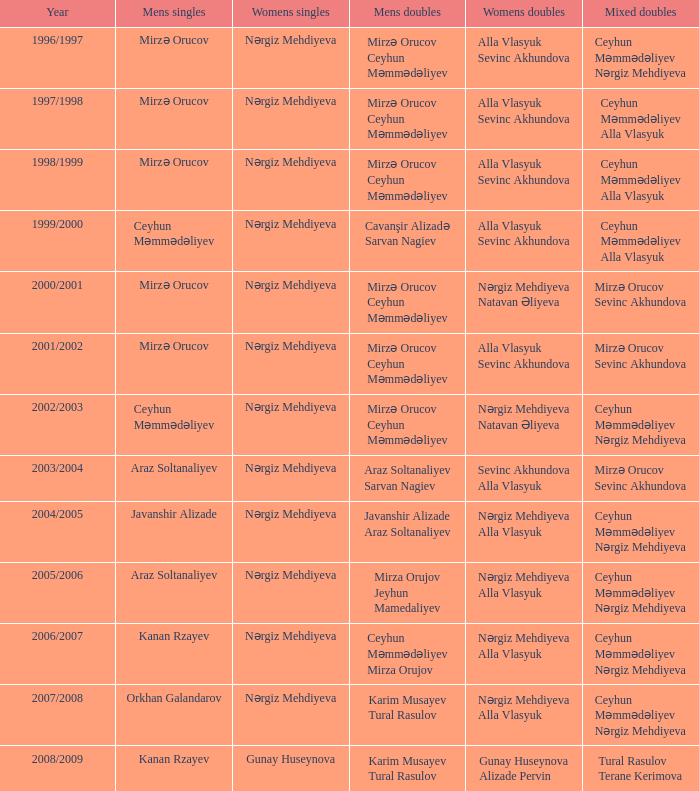Can you list the women's doubles players for the 2000/2001 year? Nərgiz Mehdiyeva Natavan Əliyeva. 